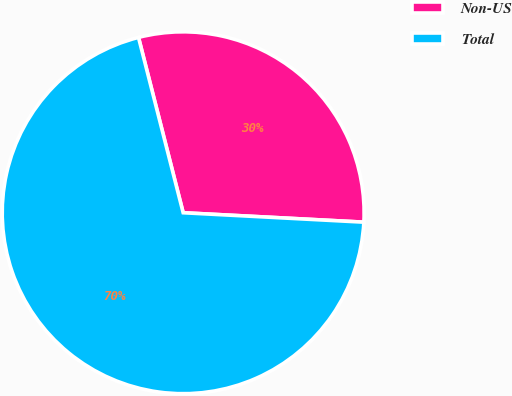Convert chart. <chart><loc_0><loc_0><loc_500><loc_500><pie_chart><fcel>Non-US<fcel>Total<nl><fcel>29.8%<fcel>70.2%<nl></chart> 